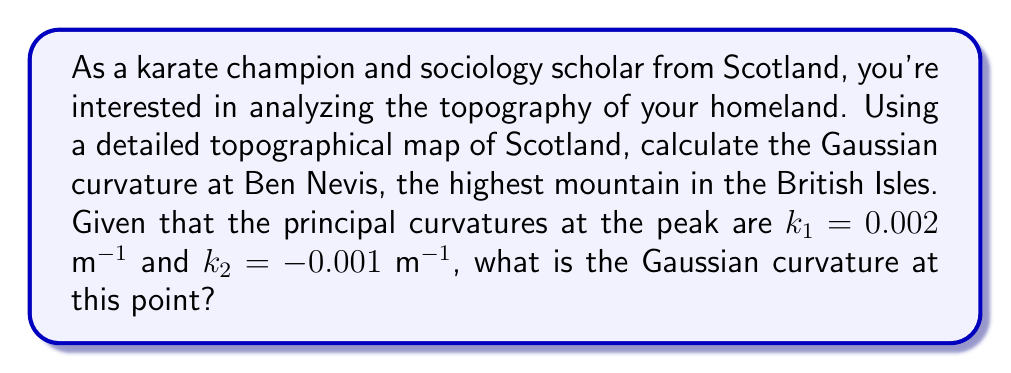Help me with this question. To solve this problem, we'll follow these steps:

1. Recall the definition of Gaussian curvature:
   The Gaussian curvature $K$ at a point on a surface is defined as the product of the principal curvatures $k_1$ and $k_2$ at that point.

   $$K = k_1 \cdot k_2$$

2. We are given the principal curvatures at the peak of Ben Nevis:
   $k_1 = 0.002$ m^(-1)
   $k_2 = -0.001$ m^(-1)

3. Substitute these values into the Gaussian curvature formula:

   $$K = (0.002 \text{ m}^{-1}) \cdot (-0.001 \text{ m}^{-1})$$

4. Multiply the values:

   $$K = -0.000002 \text{ m}^{-2}$$

5. Simplify the result:

   $$K = -2 \times 10^{-6} \text{ m}^{-2}$$

The negative Gaussian curvature indicates that the surface at the peak of Ben Nevis has a saddle-like shape, which is typical for mountain ridges or peaks.
Answer: $-2 \times 10^{-6} \text{ m}^{-2}$ 